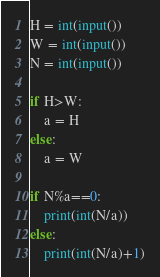Convert code to text. <code><loc_0><loc_0><loc_500><loc_500><_Python_>H = int(input())
W = int(input())
N = int(input())

if H>W:
    a = H
else:
    a = W

if N%a==0:
    print(int(N/a))
else:
    print(int(N/a)+1)</code> 